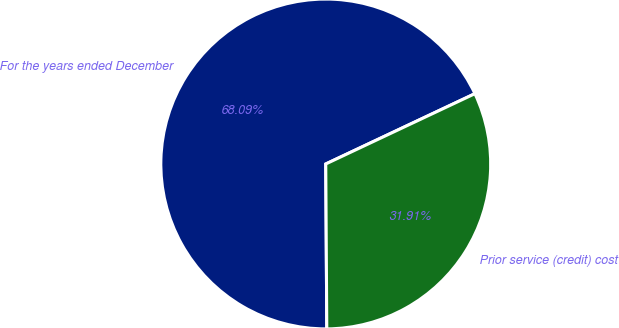<chart> <loc_0><loc_0><loc_500><loc_500><pie_chart><fcel>For the years ended December<fcel>Prior service (credit) cost<nl><fcel>68.09%<fcel>31.91%<nl></chart> 